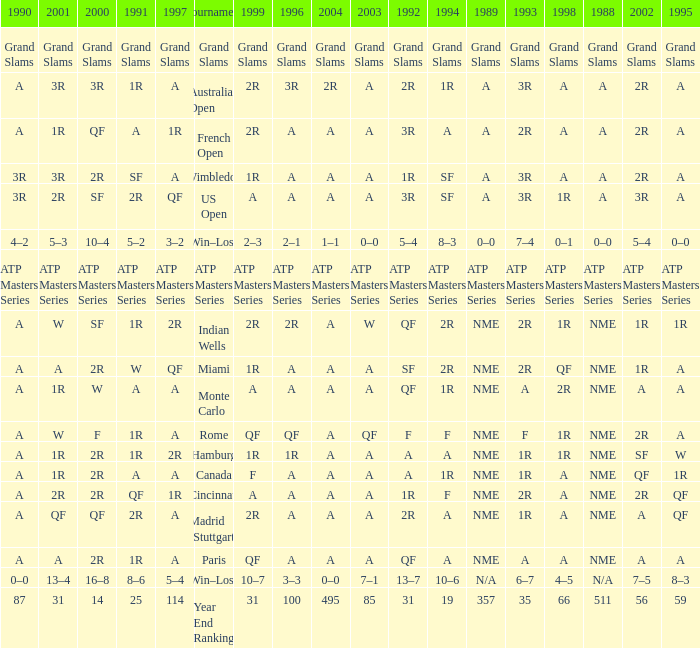I'm looking to parse the entire table for insights. Could you assist me with that? {'header': ['1990', '2001', '2000', '1991', '1997', 'Tournament', '1999', '1996', '2004', '2003', '1992', '1994', '1989', '1993', '1998', '1988', '2002', '1995'], 'rows': [['Grand Slams', 'Grand Slams', 'Grand Slams', 'Grand Slams', 'Grand Slams', 'Grand Slams', 'Grand Slams', 'Grand Slams', 'Grand Slams', 'Grand Slams', 'Grand Slams', 'Grand Slams', 'Grand Slams', 'Grand Slams', 'Grand Slams', 'Grand Slams', 'Grand Slams', 'Grand Slams'], ['A', '3R', '3R', '1R', 'A', 'Australian Open', '2R', '3R', '2R', 'A', '2R', '1R', 'A', '3R', 'A', 'A', '2R', 'A'], ['A', '1R', 'QF', 'A', '1R', 'French Open', '2R', 'A', 'A', 'A', '3R', 'A', 'A', '2R', 'A', 'A', '2R', 'A'], ['3R', '3R', '2R', 'SF', 'A', 'Wimbledon', '1R', 'A', 'A', 'A', '1R', 'SF', 'A', '3R', 'A', 'A', '2R', 'A'], ['3R', '2R', 'SF', '2R', 'QF', 'US Open', 'A', 'A', 'A', 'A', '3R', 'SF', 'A', '3R', '1R', 'A', '3R', 'A'], ['4–2', '5–3', '10–4', '5–2', '3–2', 'Win–Loss', '2–3', '2–1', '1–1', '0–0', '5–4', '8–3', '0–0', '7–4', '0–1', '0–0', '5–4', '0–0'], ['ATP Masters Series', 'ATP Masters Series', 'ATP Masters Series', 'ATP Masters Series', 'ATP Masters Series', 'ATP Masters Series', 'ATP Masters Series', 'ATP Masters Series', 'ATP Masters Series', 'ATP Masters Series', 'ATP Masters Series', 'ATP Masters Series', 'ATP Masters Series', 'ATP Masters Series', 'ATP Masters Series', 'ATP Masters Series', 'ATP Masters Series', 'ATP Masters Series'], ['A', 'W', 'SF', '1R', '2R', 'Indian Wells', '2R', '2R', 'A', 'W', 'QF', '2R', 'NME', '2R', '1R', 'NME', '1R', '1R'], ['A', 'A', '2R', 'W', 'QF', 'Miami', '1R', 'A', 'A', 'A', 'SF', '2R', 'NME', '2R', 'QF', 'NME', '1R', 'A'], ['A', '1R', 'W', 'A', 'A', 'Monte Carlo', 'A', 'A', 'A', 'A', 'QF', '1R', 'NME', 'A', '2R', 'NME', 'A', 'A'], ['A', 'W', 'F', '1R', 'A', 'Rome', 'QF', 'QF', 'A', 'QF', 'F', 'F', 'NME', 'F', '1R', 'NME', '2R', 'A'], ['A', '1R', '2R', '1R', '2R', 'Hamburg', '1R', '1R', 'A', 'A', 'A', 'A', 'NME', '1R', '1R', 'NME', 'SF', 'W'], ['A', '1R', '2R', 'A', 'A', 'Canada', 'F', 'A', 'A', 'A', 'A', '1R', 'NME', '1R', 'A', 'NME', 'QF', '1R'], ['A', '2R', '2R', 'QF', '1R', 'Cincinnati', 'A', 'A', 'A', 'A', '1R', 'F', 'NME', '2R', 'A', 'NME', '2R', 'QF'], ['A', 'QF', 'QF', '2R', 'A', 'Madrid (Stuttgart)', '2R', 'A', 'A', 'A', '2R', 'A', 'NME', '1R', 'A', 'NME', 'A', 'QF'], ['A', 'A', '2R', '1R', 'A', 'Paris', 'QF', 'A', 'A', 'A', 'QF', 'A', 'NME', 'A', 'A', 'NME', 'A', 'A'], ['0–0', '13–4', '16–8', '8–6', '5–4', 'Win–Loss', '10–7', '3–3', '0–0', '7–1', '13–7', '10–6', 'N/A', '6–7', '4–5', 'N/A', '7–5', '8–3'], ['87', '31', '14', '25', '114', 'Year End Ranking', '31', '100', '495', '85', '31', '19', '357', '35', '66', '511', '56', '59']]} What shows for 1992 when 1988 is A, at the Australian Open? 2R. 